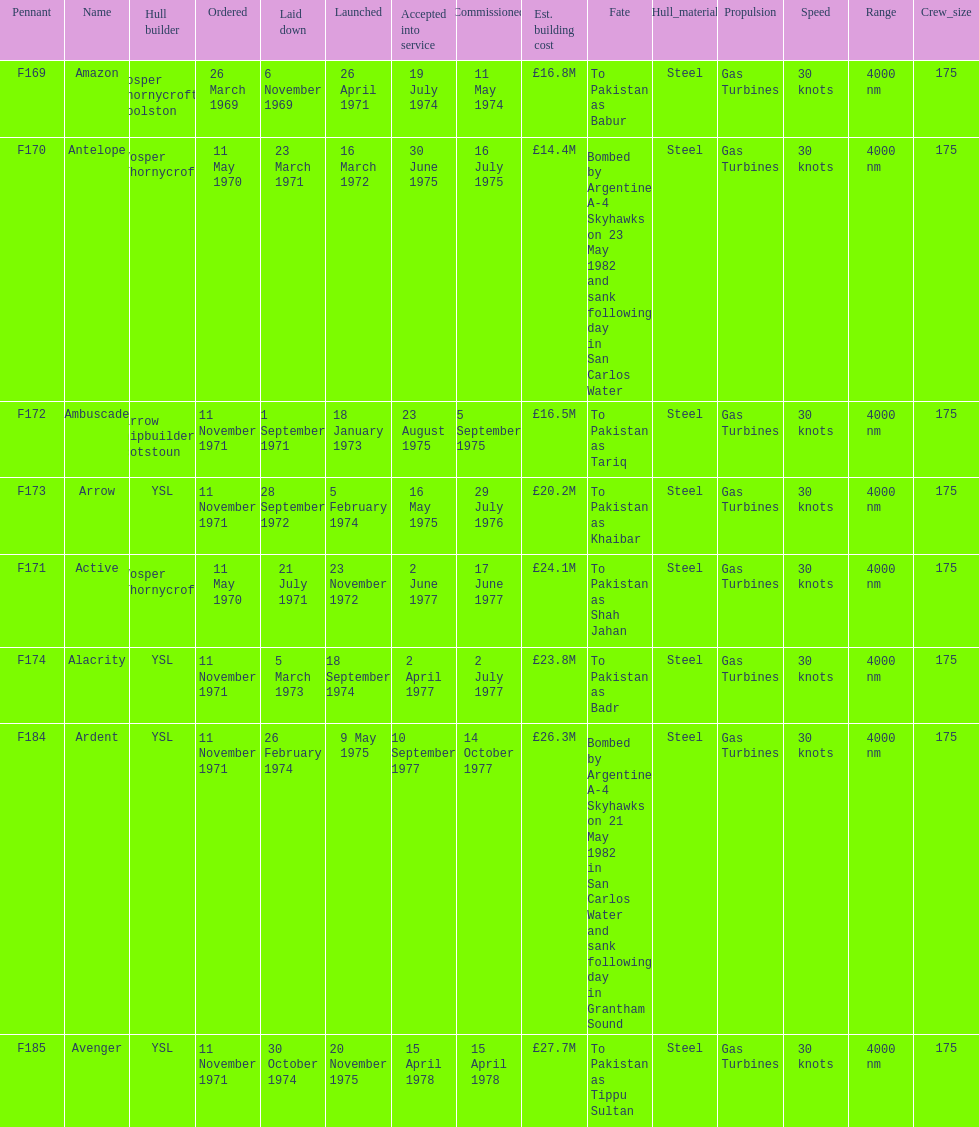What is the next pennant after f172? F173. 